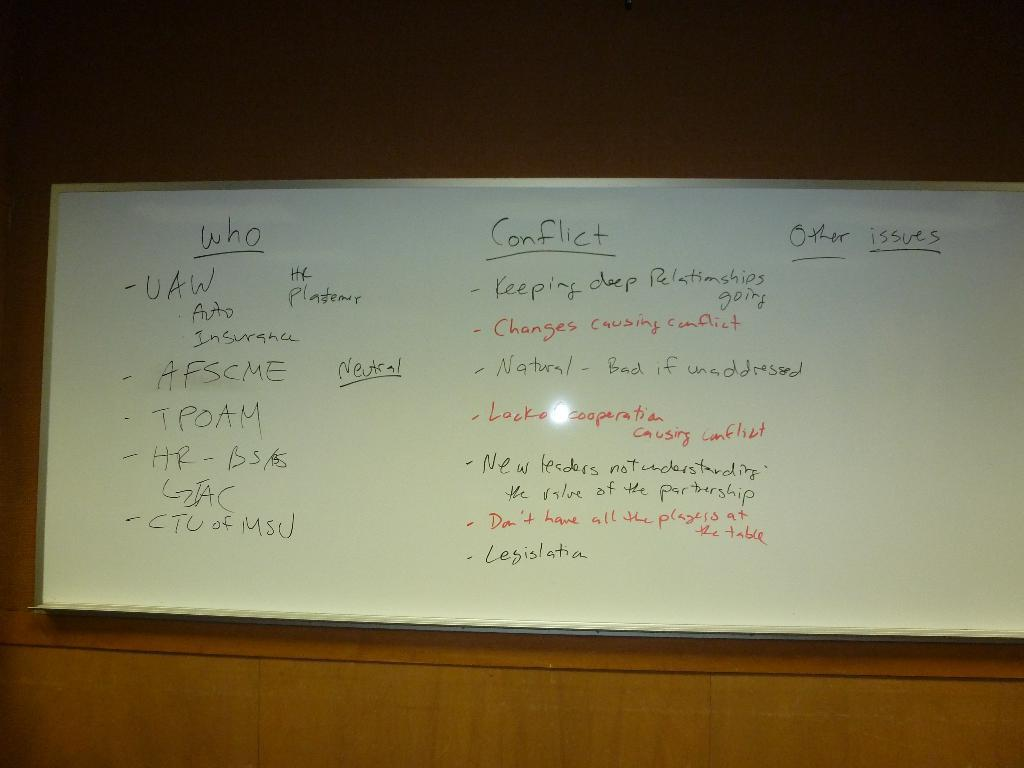What is on the wall in the image? There is a board on the wall in the image. Can you describe the setting where the board is located? The image was likely taken in a room. Can you tell me how many toads are sitting on the board in the image? There are no toads present in the image; it only features a board on the wall. What type of knowledge can be gained from the board in the image? The image does not provide any information about the content of the board, so it cannot be determined what type of knowledge might be gained from it. 